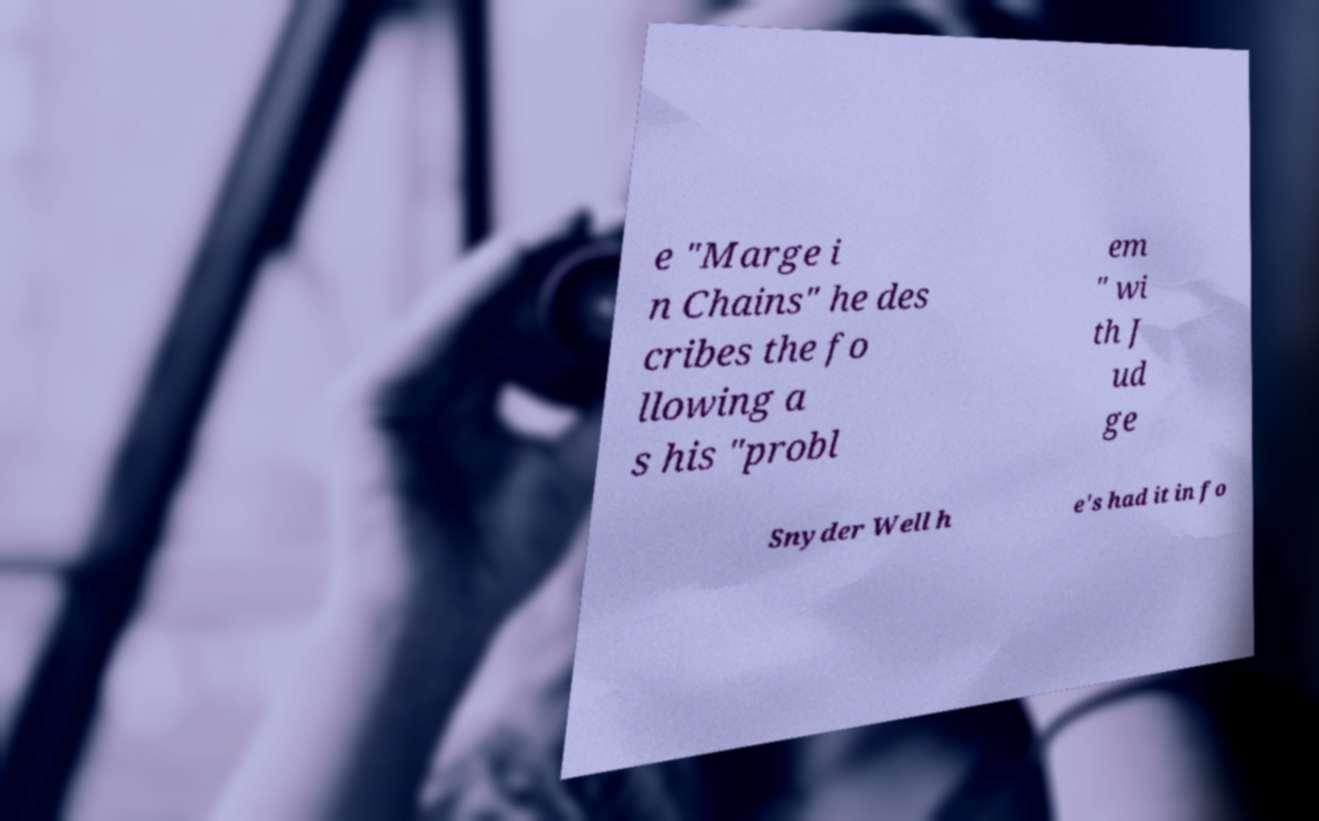What messages or text are displayed in this image? I need them in a readable, typed format. e "Marge i n Chains" he des cribes the fo llowing a s his "probl em " wi th J ud ge Snyder Well h e's had it in fo 